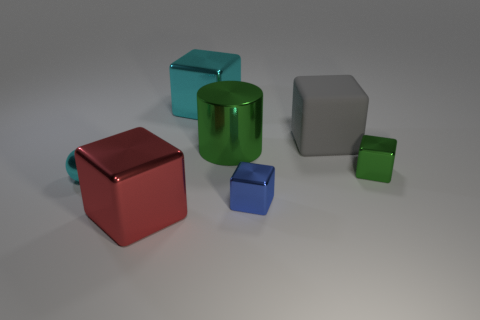What number of blocks are both on the left side of the cyan block and right of the large matte block?
Make the answer very short. 0. Is there any other thing that is the same size as the gray object?
Make the answer very short. Yes. Are there more red objects to the right of the big green metal object than small blue things that are on the right side of the blue object?
Make the answer very short. No. There is a cylinder that is behind the red thing; what is its material?
Your answer should be compact. Metal. There is a blue metal object; is it the same shape as the cyan shiny thing that is behind the gray cube?
Give a very brief answer. Yes. How many green metal cubes are in front of the cyan metal object that is left of the big object that is in front of the big green shiny cylinder?
Your answer should be compact. 0. There is another tiny object that is the same shape as the small green object; what color is it?
Your response must be concise. Blue. Are there any other things that have the same shape as the tiny blue metal object?
Keep it short and to the point. Yes. What number of cubes are either small cyan metallic objects or green metallic things?
Your answer should be compact. 1. What shape is the large green object?
Your response must be concise. Cylinder. 